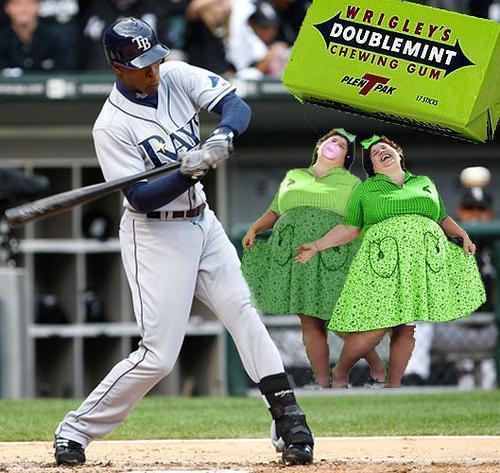How many people are there?
Give a very brief answer. 4. How many cats are on the sink?
Give a very brief answer. 0. 